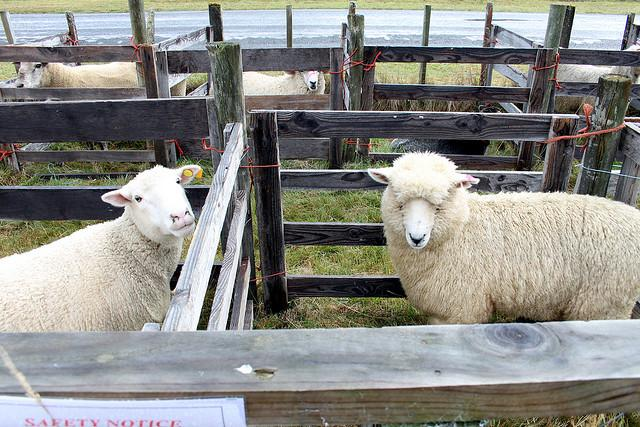What color is the twine that is tied between the cages carrying sheep?

Choices:
A) green
B) pink
C) red
D) blue red 